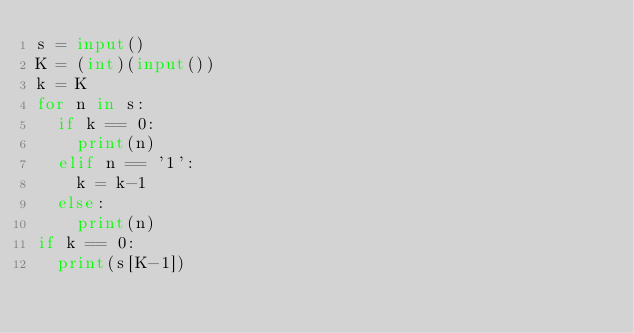<code> <loc_0><loc_0><loc_500><loc_500><_Python_>s = input()
K = (int)(input())
k = K
for n in s:
  if k == 0:
    print(n)
  elif n == '1':
    k = k-1
  else:
    print(n)
if k == 0:
  print(s[K-1])
</code> 